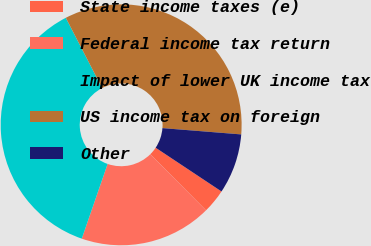<chart> <loc_0><loc_0><loc_500><loc_500><pie_chart><fcel>State income taxes (e)<fcel>Federal income tax return<fcel>Impact of lower UK income tax<fcel>US income tax on foreign<fcel>Other<nl><fcel>3.23%<fcel>17.74%<fcel>37.1%<fcel>33.87%<fcel>8.06%<nl></chart> 